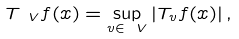Convert formula to latex. <formula><loc_0><loc_0><loc_500><loc_500>T _ { \ V } f ( x ) = \sup _ { v \in \ V } \left | T _ { v } f ( x ) \right | ,</formula> 